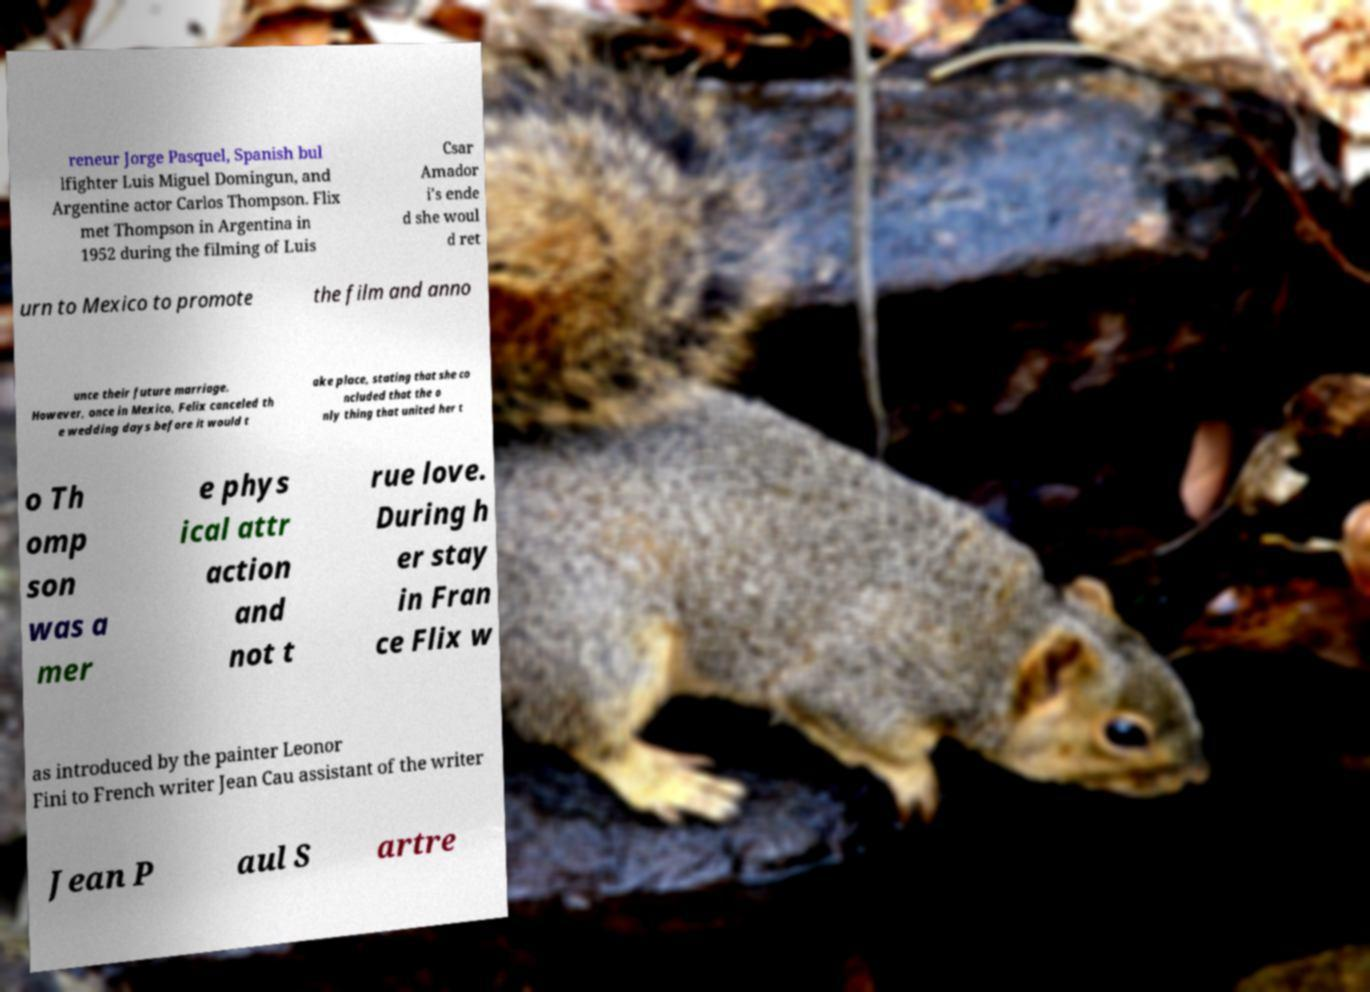Please identify and transcribe the text found in this image. reneur Jorge Pasquel, Spanish bul lfighter Luis Miguel Domingun, and Argentine actor Carlos Thompson. Flix met Thompson in Argentina in 1952 during the filming of Luis Csar Amador i's ende d she woul d ret urn to Mexico to promote the film and anno unce their future marriage. However, once in Mexico, Felix canceled th e wedding days before it would t ake place, stating that she co ncluded that the o nly thing that united her t o Th omp son was a mer e phys ical attr action and not t rue love. During h er stay in Fran ce Flix w as introduced by the painter Leonor Fini to French writer Jean Cau assistant of the writer Jean P aul S artre 